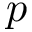Convert formula to latex. <formula><loc_0><loc_0><loc_500><loc_500>p</formula> 